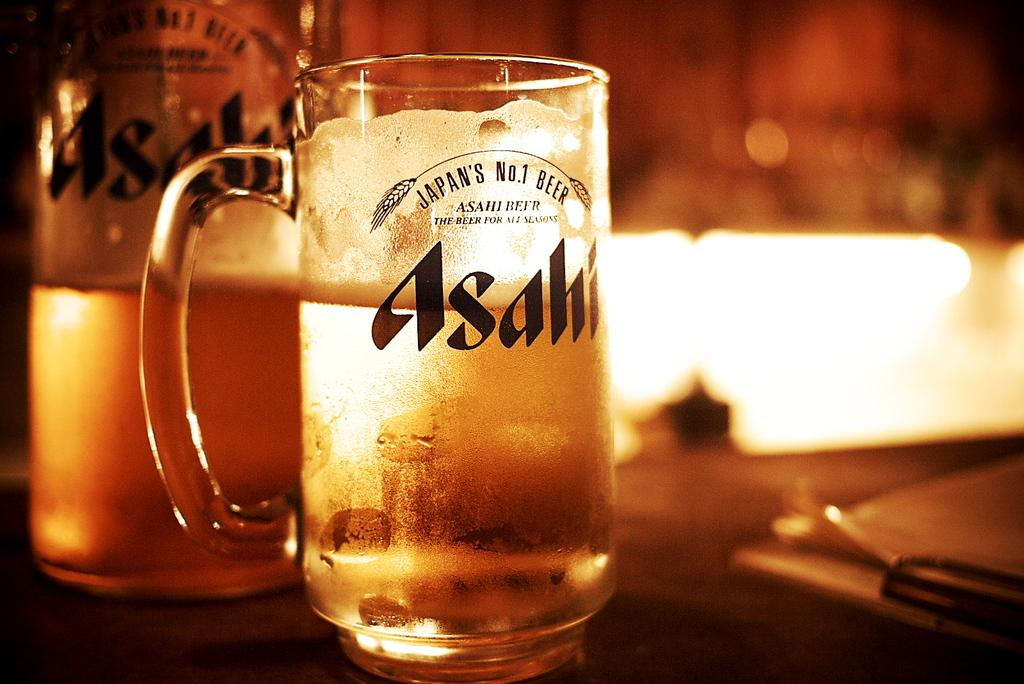<image>
Present a compact description of the photo's key features. A glass of Japan's No. 1 beer sits on a bar with moody lighting. 